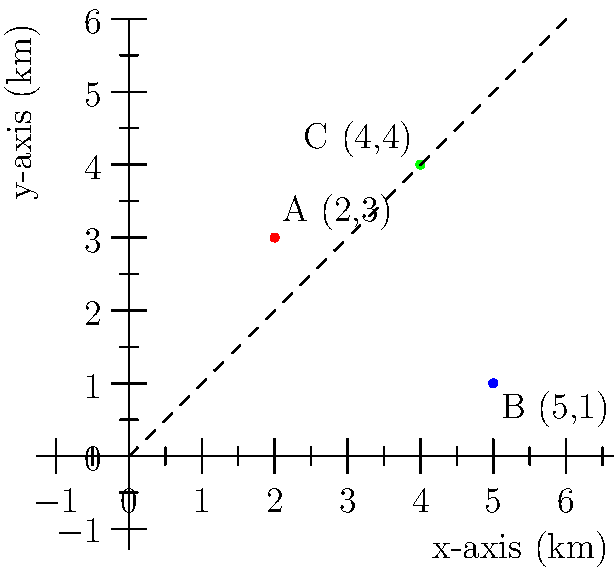A fashion retail company is planning to open three new stores in a city. The locations are represented on a coordinate system where each unit represents 1 km. Store A is at (2,3), Store B is at (5,1), and Store C is at (4,4). What is the Manhattan distance between Store A and Store B? To solve this problem, we need to understand the concept of Manhattan distance and apply it to the given coordinates:

1. Manhattan distance is the sum of the absolute differences of the x and y coordinates.

2. The formula for Manhattan distance is:
   $d = |x_2 - x_1| + |y_2 - y_1|$

3. For Store A: $(x_1, y_1) = (2, 3)$
   For Store B: $(x_2, y_2) = (5, 1)$

4. Plugging these into the formula:
   $d = |5 - 2| + |1 - 3|$

5. Simplify:
   $d = |3| + |-2|$

6. Calculate the absolute values:
   $d = 3 + 2 = 5$

Therefore, the Manhattan distance between Store A and Store B is 5 km.
Answer: 5 km 